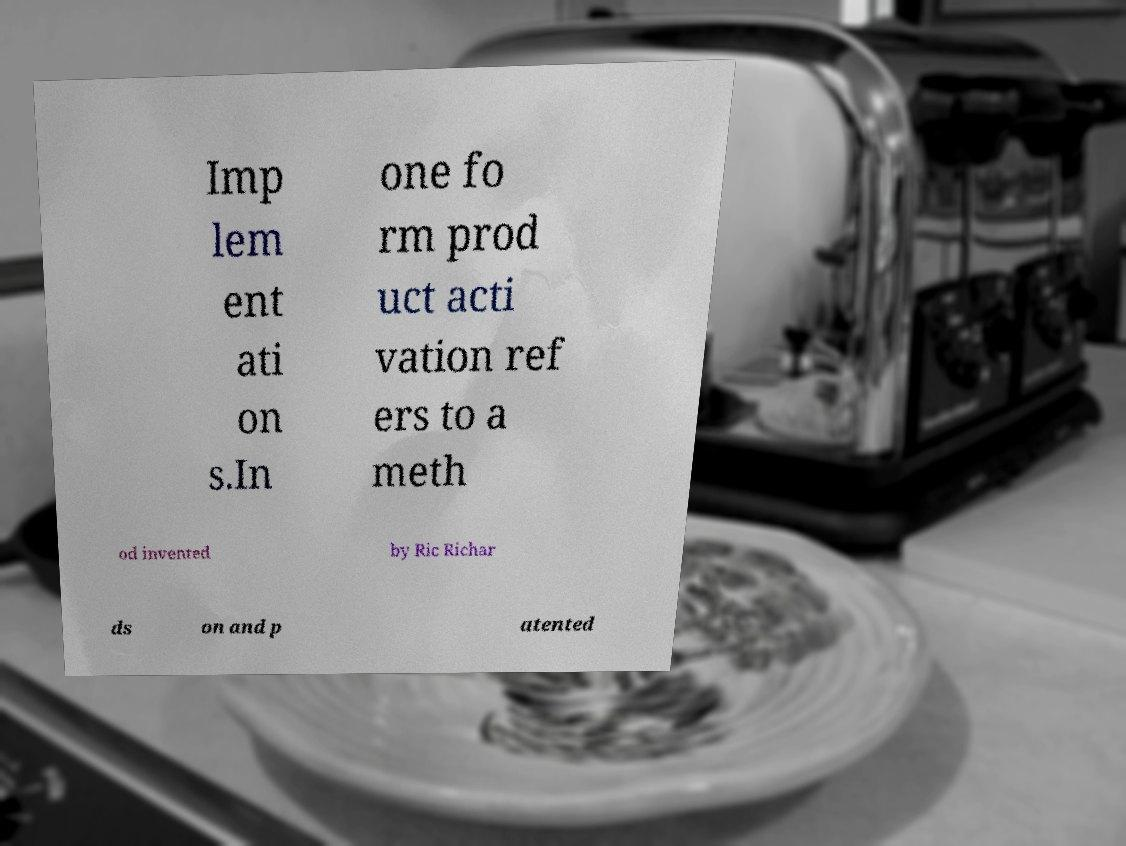Could you assist in decoding the text presented in this image and type it out clearly? Imp lem ent ati on s.In one fo rm prod uct acti vation ref ers to a meth od invented by Ric Richar ds on and p atented 